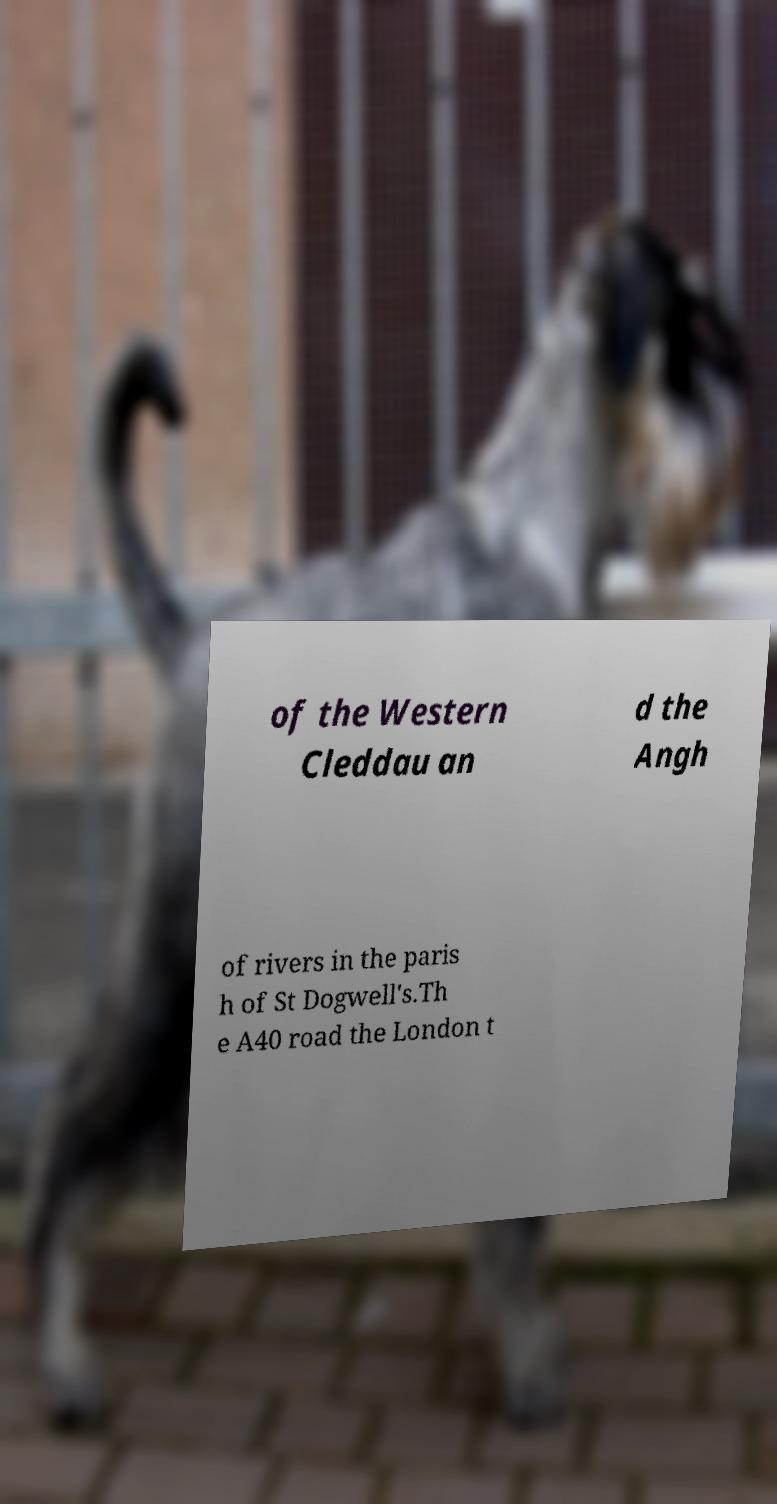Could you extract and type out the text from this image? of the Western Cleddau an d the Angh of rivers in the paris h of St Dogwell's.Th e A40 road the London t 